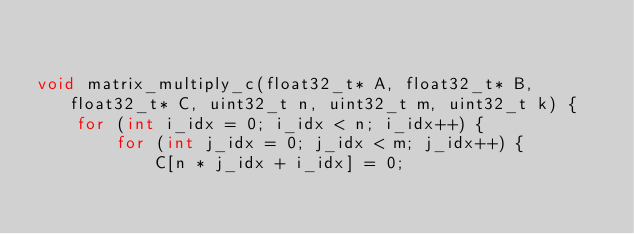<code> <loc_0><loc_0><loc_500><loc_500><_C++_>

void matrix_multiply_c(float32_t* A, float32_t* B, float32_t* C, uint32_t n, uint32_t m, uint32_t k) {
    for (int i_idx = 0; i_idx < n; i_idx++) {
        for (int j_idx = 0; j_idx < m; j_idx++) {
            C[n * j_idx + i_idx] = 0;</code> 